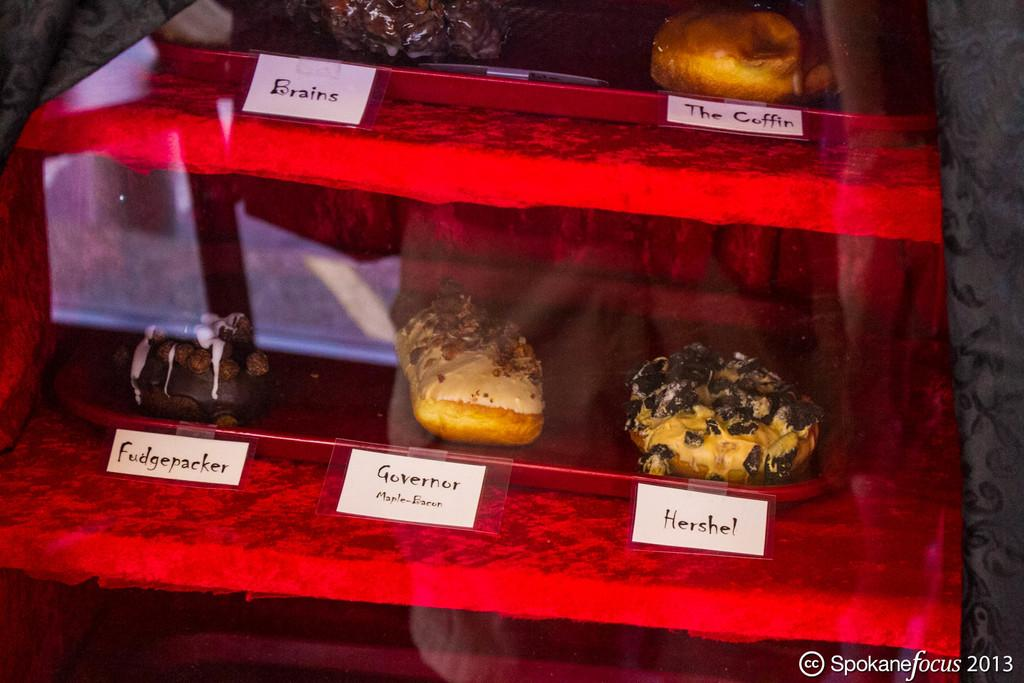<image>
Create a compact narrative representing the image presented. A case of a variety of dounuts with a name tags below the doughnuts including, Brains, The Coffin, Frankenstein, Governor, and Hershel. 